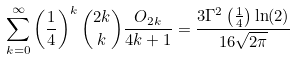Convert formula to latex. <formula><loc_0><loc_0><loc_500><loc_500>\sum _ { k = 0 } ^ { \infty } \left ( \frac { 1 } { 4 } \right ) ^ { k } \binom { 2 k } { k } \frac { O _ { 2 k } } { 4 k + 1 } = \frac { 3 \Gamma ^ { 2 } \left ( \frac { 1 } { 4 } \right ) \ln ( 2 ) } { 1 6 \sqrt { 2 \pi } }</formula> 